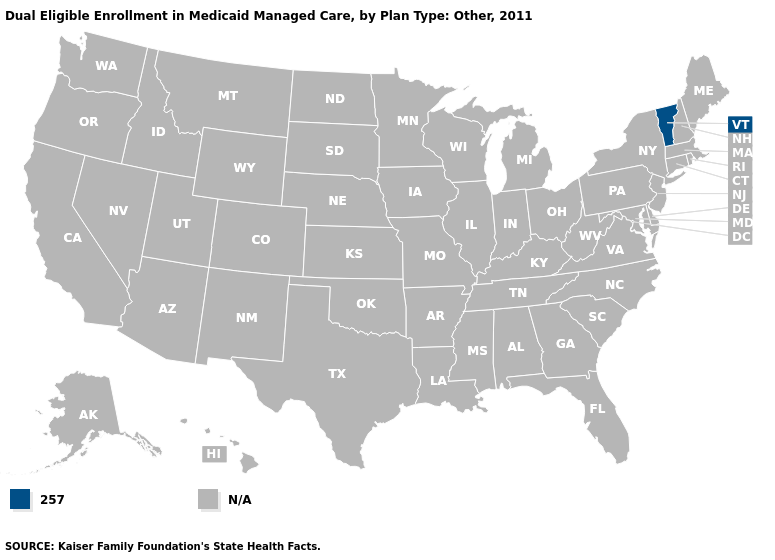Which states have the lowest value in the Northeast?
Quick response, please. Vermont. What is the value of Wisconsin?
Give a very brief answer. N/A. Name the states that have a value in the range N/A?
Answer briefly. Alabama, Alaska, Arizona, Arkansas, California, Colorado, Connecticut, Delaware, Florida, Georgia, Hawaii, Idaho, Illinois, Indiana, Iowa, Kansas, Kentucky, Louisiana, Maine, Maryland, Massachusetts, Michigan, Minnesota, Mississippi, Missouri, Montana, Nebraska, Nevada, New Hampshire, New Jersey, New Mexico, New York, North Carolina, North Dakota, Ohio, Oklahoma, Oregon, Pennsylvania, Rhode Island, South Carolina, South Dakota, Tennessee, Texas, Utah, Virginia, Washington, West Virginia, Wisconsin, Wyoming. What is the value of North Carolina?
Give a very brief answer. N/A. Name the states that have a value in the range N/A?
Keep it brief. Alabama, Alaska, Arizona, Arkansas, California, Colorado, Connecticut, Delaware, Florida, Georgia, Hawaii, Idaho, Illinois, Indiana, Iowa, Kansas, Kentucky, Louisiana, Maine, Maryland, Massachusetts, Michigan, Minnesota, Mississippi, Missouri, Montana, Nebraska, Nevada, New Hampshire, New Jersey, New Mexico, New York, North Carolina, North Dakota, Ohio, Oklahoma, Oregon, Pennsylvania, Rhode Island, South Carolina, South Dakota, Tennessee, Texas, Utah, Virginia, Washington, West Virginia, Wisconsin, Wyoming. Which states have the lowest value in the USA?
Answer briefly. Vermont. What is the value of Kansas?
Be succinct. N/A. Does the map have missing data?
Give a very brief answer. Yes. Name the states that have a value in the range N/A?
Write a very short answer. Alabama, Alaska, Arizona, Arkansas, California, Colorado, Connecticut, Delaware, Florida, Georgia, Hawaii, Idaho, Illinois, Indiana, Iowa, Kansas, Kentucky, Louisiana, Maine, Maryland, Massachusetts, Michigan, Minnesota, Mississippi, Missouri, Montana, Nebraska, Nevada, New Hampshire, New Jersey, New Mexico, New York, North Carolina, North Dakota, Ohio, Oklahoma, Oregon, Pennsylvania, Rhode Island, South Carolina, South Dakota, Tennessee, Texas, Utah, Virginia, Washington, West Virginia, Wisconsin, Wyoming. 